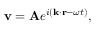Convert formula to latex. <formula><loc_0><loc_0><loc_500><loc_500>v = A e ^ { i ( k \cdot r - \omega t ) } ,</formula> 